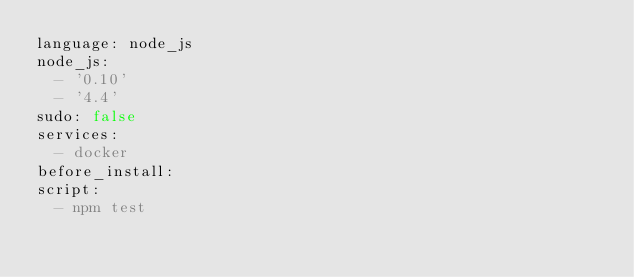Convert code to text. <code><loc_0><loc_0><loc_500><loc_500><_YAML_>language: node_js
node_js:
  - '0.10'
  - '4.4'
sudo: false
services:
  - docker
before_install:
script:
  - npm test</code> 